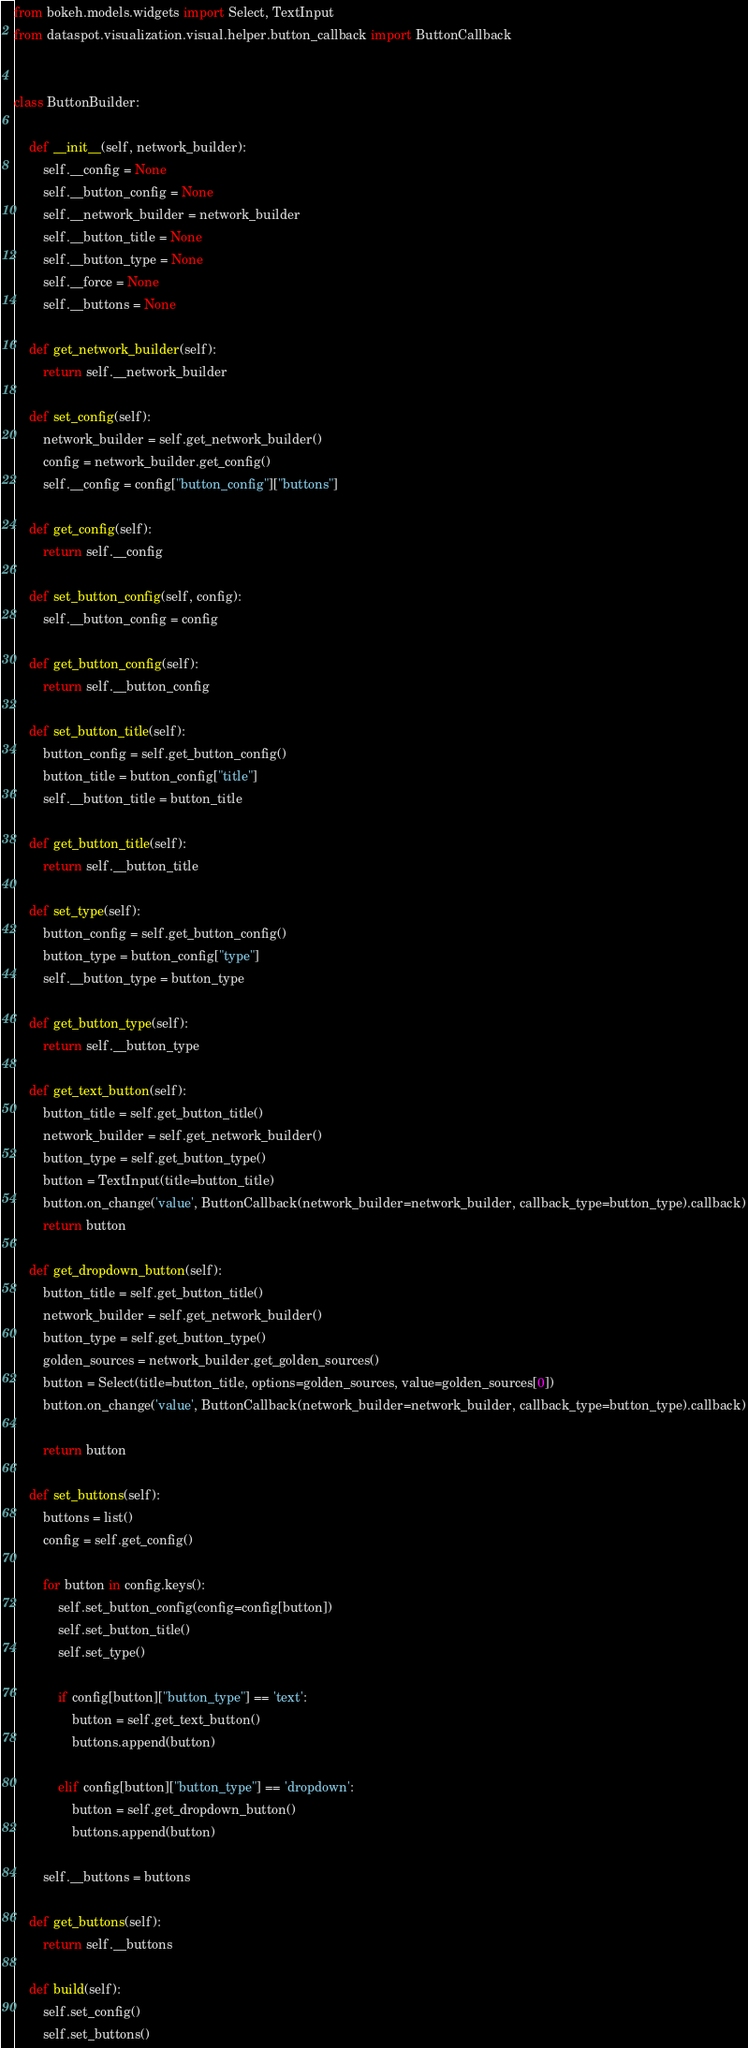<code> <loc_0><loc_0><loc_500><loc_500><_Python_>from bokeh.models.widgets import Select, TextInput
from dataspot.visualization.visual.helper.button_callback import ButtonCallback


class ButtonBuilder:

    def __init__(self, network_builder):
        self.__config = None
        self.__button_config = None
        self.__network_builder = network_builder
        self.__button_title = None
        self.__button_type = None
        self.__force = None
        self.__buttons = None

    def get_network_builder(self):
        return self.__network_builder

    def set_config(self):
        network_builder = self.get_network_builder()
        config = network_builder.get_config()
        self.__config = config["button_config"]["buttons"]

    def get_config(self):
        return self.__config

    def set_button_config(self, config):
        self.__button_config = config

    def get_button_config(self):
        return self.__button_config

    def set_button_title(self):
        button_config = self.get_button_config()
        button_title = button_config["title"]
        self.__button_title = button_title

    def get_button_title(self):
        return self.__button_title

    def set_type(self):
        button_config = self.get_button_config()
        button_type = button_config["type"]
        self.__button_type = button_type

    def get_button_type(self):
        return self.__button_type

    def get_text_button(self):
        button_title = self.get_button_title()
        network_builder = self.get_network_builder()
        button_type = self.get_button_type()
        button = TextInput(title=button_title)
        button.on_change('value', ButtonCallback(network_builder=network_builder, callback_type=button_type).callback)
        return button

    def get_dropdown_button(self):
        button_title = self.get_button_title()
        network_builder = self.get_network_builder()
        button_type = self.get_button_type()
        golden_sources = network_builder.get_golden_sources()
        button = Select(title=button_title, options=golden_sources, value=golden_sources[0])
        button.on_change('value', ButtonCallback(network_builder=network_builder, callback_type=button_type).callback)

        return button

    def set_buttons(self):
        buttons = list()
        config = self.get_config()

        for button in config.keys():
            self.set_button_config(config=config[button])
            self.set_button_title()
            self.set_type()

            if config[button]["button_type"] == 'text':
                button = self.get_text_button()
                buttons.append(button)

            elif config[button]["button_type"] == 'dropdown':
                button = self.get_dropdown_button()
                buttons.append(button)

        self.__buttons = buttons

    def get_buttons(self):
        return self.__buttons

    def build(self):
        self.set_config()
        self.set_buttons()
</code> 